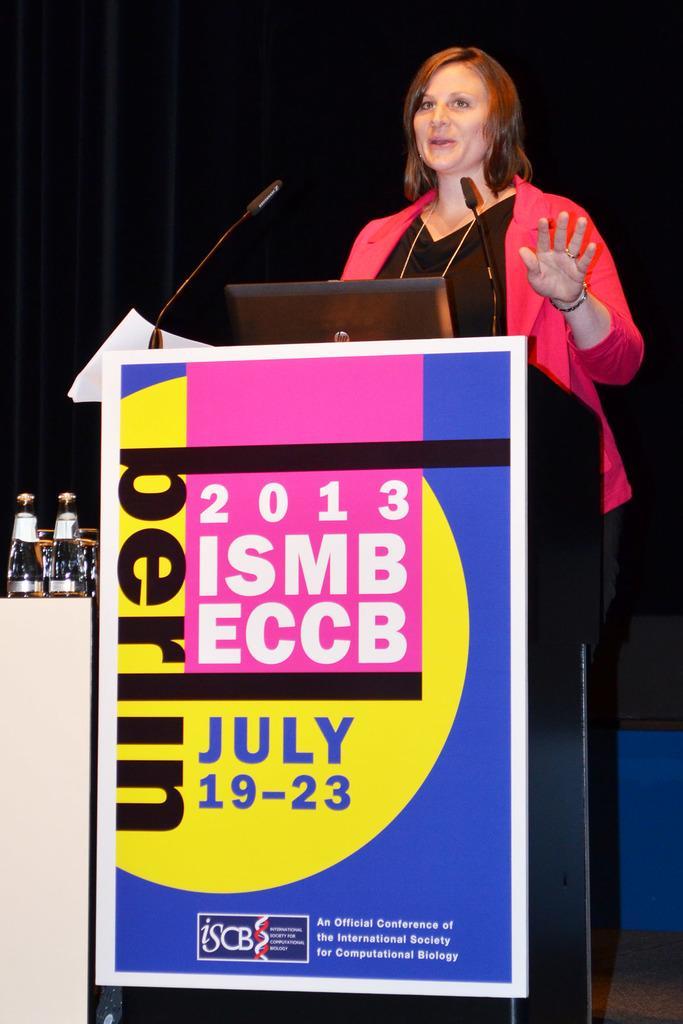Can you describe this image briefly? In this image there is a woman standing. In front of her there is a podium. There are microphones and a laptop on the podium. There is a banner with text on the podium. Behind her there is a curtain. To the left there are bottles on the table. 